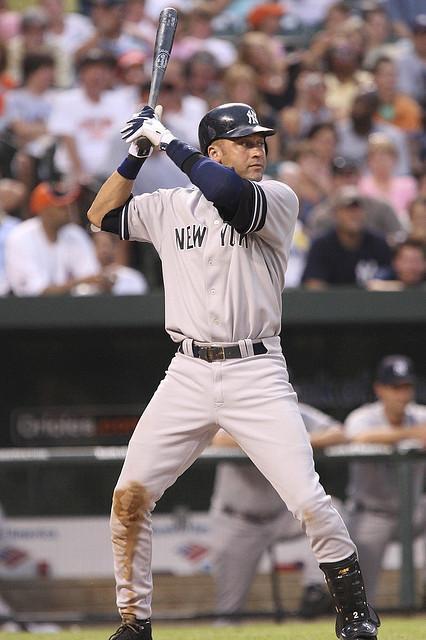How many people are there?
Give a very brief answer. 11. How many stuffed giraffes are there?
Give a very brief answer. 0. 